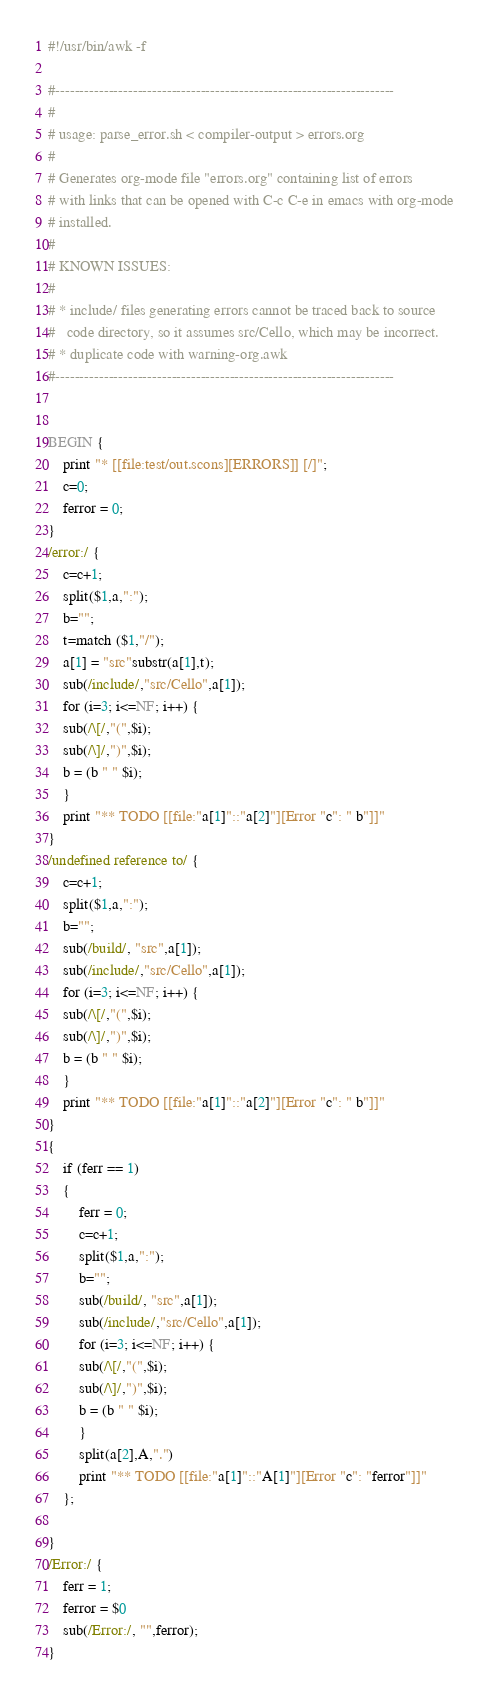<code> <loc_0><loc_0><loc_500><loc_500><_Awk_>#!/usr/bin/awk -f

#----------------------------------------------------------------------
#
# usage: parse_error.sh < compiler-output > errors.org
#
# Generates org-mode file "errors.org" containing list of errors
# with links that can be opened with C-c C-e in emacs with org-mode
# installed.
#
# KNOWN ISSUES:
#
# * include/ files generating errors cannot be traced back to source
#   code directory, so it assumes src/Cello, which may be incorrect.
# * duplicate code with warning-org.awk
#----------------------------------------------------------------------


BEGIN {
    print "* [[file:test/out.scons][ERRORS]] [/]";
    c=0;
    ferror = 0;
}
/error:/ {
    c=c+1; 
    split($1,a,":"); 
    b="";  
    t=match ($1,"/");
    a[1] = "src"substr(a[1],t);
    sub(/include/,"src/Cello",a[1]);
    for (i=3; i<=NF; i++) {
	sub(/\[/,"(",$i);
	sub(/\]/,")",$i);
	b = (b " " $i); 
    }
    print "** TODO [[file:"a[1]"::"a[2]"][Error "c": " b"]]"
}
/undefined reference to/ {
    c=c+1; 
    split($1,a,":"); 
    b="";  
    sub(/build/, "src",a[1]); 
    sub(/include/,"src/Cello",a[1]);
    for (i=3; i<=NF; i++) {
	sub(/\[/,"(",$i);
	sub(/\]/,")",$i);
	b = (b " " $i); 
    }
    print "** TODO [[file:"a[1]"::"a[2]"][Error "c": " b"]]"
}
{
    if (ferr == 1) 
	{
	    ferr = 0;
	    c=c+1; 
	    split($1,a,":"); 
	    b="";  
	    sub(/build/, "src",a[1]); 
	    sub(/include/,"src/Cello",a[1]);
	    for (i=3; i<=NF; i++) {
		sub(/\[/,"(",$i);
		sub(/\]/,")",$i);
		b = (b " " $i); 
	    }
	    split(a[2],A,".")
	    print "** TODO [[file:"a[1]"::"A[1]"][Error "c": "ferror"]]"
	};
	
}
/Error:/ {
    ferr = 1;
    ferror = $0
    sub(/Error:/, "",ferror); 
}
</code> 